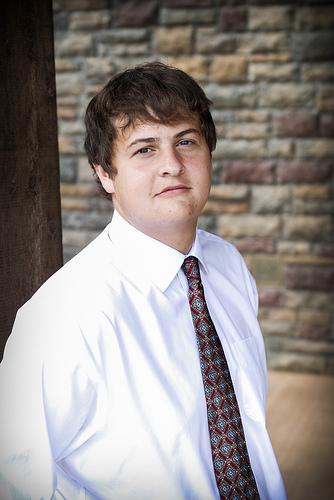Point out the background elements in the image. In the background, there is a brick wall, a wooden post, a stone building, and a tree near the young man. How would you describe the location where the young man is standing? The young man is standing outside of a building on a sidewalk next to a brick wall and a tree. What are some facial features of the person in the image? The young man has brown hair, brown eyes, a pair of brown eyebrows, and acne on his face. Count and describe the number of objects identified in the image. There are a total of 32 objects identified in the image, including the young man, his clothing, facial features, and background elements like the wall, tree, and building. Identify the main object in the image and its color and pattern. The main object in the image is a young man wearing a white collared shirt and a red tie with a triangle pattern. Mention any accessories or additional clothing items that the man is wearing. The man is wearing a tie and has a pocket and collar on his white shirt. Analyze the interaction between the objects in the image. The young man is wearing a white shirt and red tie while standing against a brick wall and a wooden post, near a tree and a stone building. He seems to be posing for the camera. Assess the image sentiment and describe the mood of the person. The image sentiment is neutral. The young man appears to be posing for the camera with a calm and relaxed facial expression. What type of pattern does the man's tie have and what are the colors present in it? The man's tie has a triangle pattern and features red, white, blue, and beige colors. Describe the quality of the image considering details and overall appearance. The image is of high quality as it provides detailed information about the young man's facial features, clothing, and the background elements. Is the building made of stone situated on a hill? The captions only provide details about the position and size of the building and that it is made of stone, but there is no information about its surrounding landscape. Is the tree next to the young man green in color? The caption only provides information about the position and size of the tree, but not about its color. Is the wooden post behind the young man painted yellow? There is no information given about the color of the wooden post, just its position and size. Are there any birds sitting on the brick wall? The captions mention a brick wall, its position, and size, but there is no information provided about any animals or birds being present in the scene. Does the tie the young man is wearing feature a striped pattern? The information provided mentions a red, white, blue, and beige design on the tie, but it does not describe the pattern as being striped. Does the young man have a beard? The captions describe various features of the young man's face like eyes, nose, mouth, and even acne, but no mention of facial hair is made. 